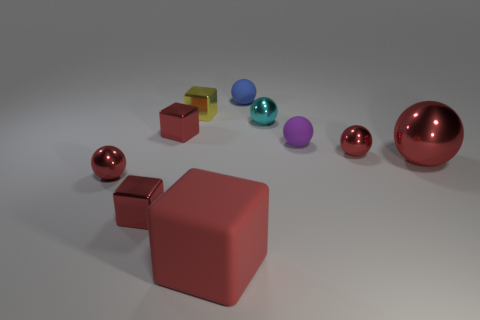Is there any other thing that has the same material as the large red ball?
Your answer should be compact. Yes. Is there a yellow metallic thing behind the small red thing on the right side of the large rubber block?
Offer a terse response. Yes. How many other objects are the same color as the big cube?
Keep it short and to the point. 5. What is the color of the matte block?
Ensure brevity in your answer.  Red. There is a object that is both to the right of the tiny yellow metallic object and behind the small cyan ball; what size is it?
Offer a terse response. Small. How many objects are red things to the right of the big red block or yellow things?
Keep it short and to the point. 3. There is a big red thing that is made of the same material as the blue sphere; what is its shape?
Offer a terse response. Cube. What is the shape of the red matte object?
Give a very brief answer. Cube. There is a thing that is behind the cyan metallic ball and left of the tiny blue matte object; what color is it?
Offer a terse response. Yellow. The cyan object that is the same size as the yellow object is what shape?
Provide a short and direct response. Sphere. 